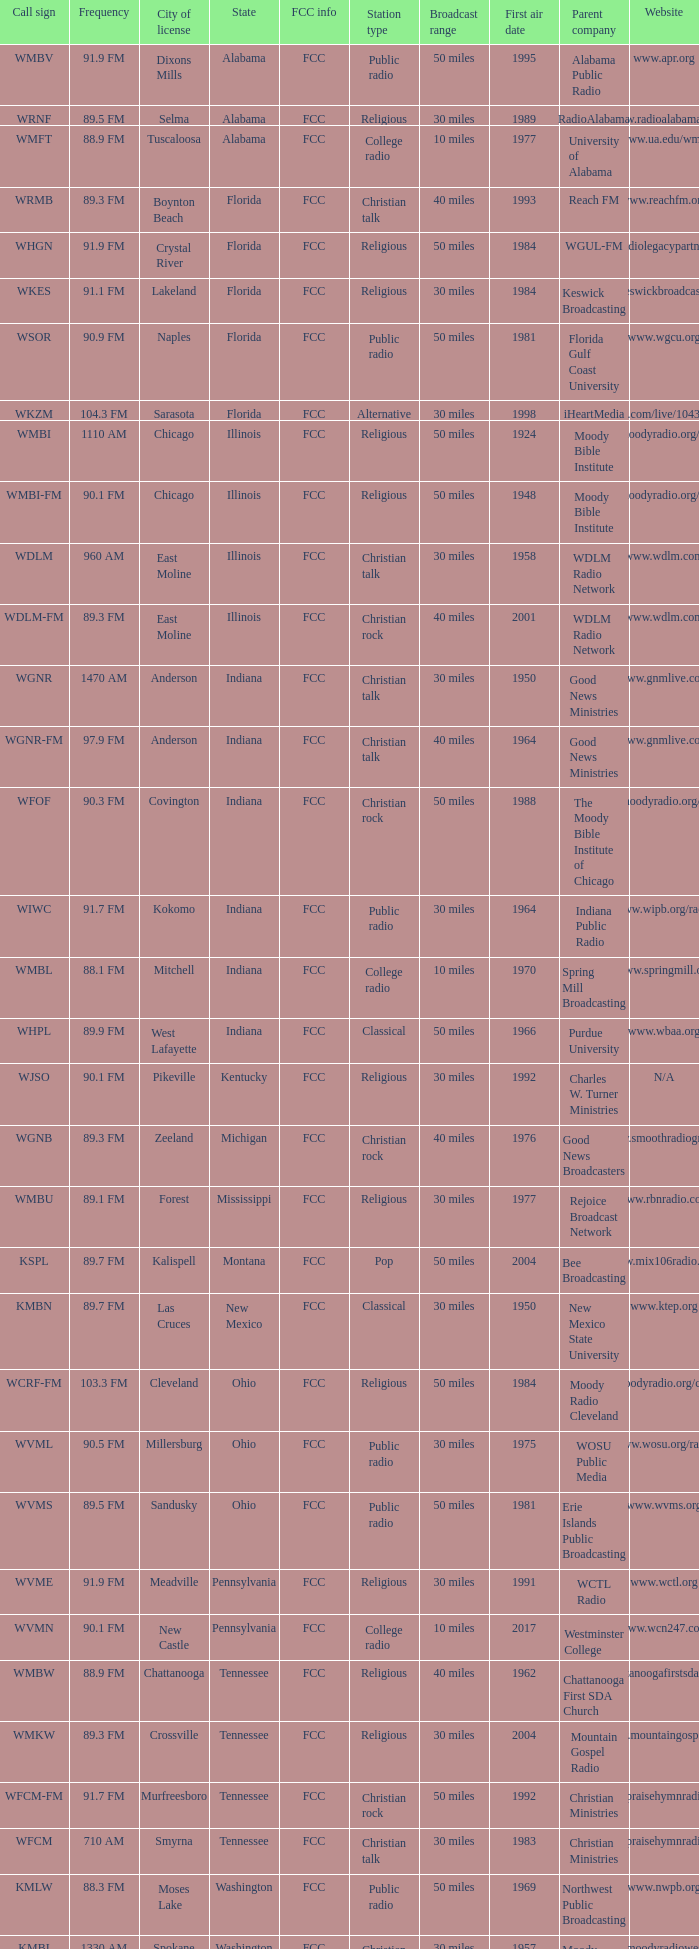What frequency does the wgnr-fm radio station operate on? 97.9 FM. Can you parse all the data within this table? {'header': ['Call sign', 'Frequency', 'City of license', 'State', 'FCC info', 'Station type', 'Broadcast range', 'First air date', 'Parent company', 'Website'], 'rows': [['WMBV', '91.9 FM', 'Dixons Mills', 'Alabama', 'FCC', 'Public radio', '50 miles', '1995', 'Alabama Public Radio', 'www.apr.org'], ['WRNF', '89.5 FM', 'Selma', 'Alabama', 'FCC', 'Religious', '30 miles', '1989', 'RadioAlabama', 'www.radioalabama.net'], ['WMFT', '88.9 FM', 'Tuscaloosa', 'Alabama', 'FCC', 'College radio', '10 miles', '1977', 'University of Alabama', 'www.ua.edu/wmft'], ['WRMB', '89.3 FM', 'Boynton Beach', 'Florida', 'FCC', 'Christian talk', '40 miles', '1993', 'Reach FM', 'www.reachfm.org'], ['WHGN', '91.9 FM', 'Crystal River', 'Florida', 'FCC', 'Religious', '50 miles', '1984', 'WGUL-FM', 'www.radiolegacypartners.com'], ['WKES', '91.1 FM', 'Lakeland', 'Florida', 'FCC', 'Religious', '30 miles', '1984', 'Keswick Broadcasting', 'www.keswickbroadcasting.org'], ['WSOR', '90.9 FM', 'Naples', 'Florida', 'FCC', 'Public radio', '50 miles', '1981', 'Florida Gulf Coast University', 'www.wgcu.org'], ['WKZM', '104.3 FM', 'Sarasota', 'Florida', 'FCC', 'Alternative', '30 miles', '1998', 'iHeartMedia', 'www.iheart.com/live/1043-kzm-4921/'], ['WMBI', '1110 AM', 'Chicago', 'Illinois', 'FCC', 'Religious', '50 miles', '1924', 'Moody Bible Institute', 'www.moodyradio.org/chicago'], ['WMBI-FM', '90.1 FM', 'Chicago', 'Illinois', 'FCC', 'Religious', '50 miles', '1948', 'Moody Bible Institute', 'www.moodyradio.org/chicago'], ['WDLM', '960 AM', 'East Moline', 'Illinois', 'FCC', 'Christian talk', '30 miles', '1958', 'WDLM Radio Network', 'www.wdlm.com'], ['WDLM-FM', '89.3 FM', 'East Moline', 'Illinois', 'FCC', 'Christian rock', '40 miles', '2001', 'WDLM Radio Network', 'www.wdlm.com'], ['WGNR', '1470 AM', 'Anderson', 'Indiana', 'FCC', 'Christian talk', '30 miles', '1950', 'Good News Ministries', 'www.gnmlive.com'], ['WGNR-FM', '97.9 FM', 'Anderson', 'Indiana', 'FCC', 'Christian talk', '40 miles', '1964', 'Good News Ministries', 'www.gnmlive.com'], ['WFOF', '90.3 FM', 'Covington', 'Indiana', 'FCC', 'Christian rock', '50 miles', '1988', 'The Moody Bible Institute of Chicago', 'www.moodyradio.org/indiana'], ['WIWC', '91.7 FM', 'Kokomo', 'Indiana', 'FCC', 'Public radio', '30 miles', '1964', 'Indiana Public Radio', 'www.wipb.org/radio'], ['WMBL', '88.1 FM', 'Mitchell', 'Indiana', 'FCC', 'College radio', '10 miles', '1970', 'Spring Mill Broadcasting', 'www.springmill.org'], ['WHPL', '89.9 FM', 'West Lafayette', 'Indiana', 'FCC', 'Classical', '50 miles', '1966', 'Purdue University', 'www.wbaa.org'], ['WJSO', '90.1 FM', 'Pikeville', 'Kentucky', 'FCC', 'Religious', '30 miles', '1992', 'Charles W. Turner Ministries', 'N/A'], ['WGNB', '89.3 FM', 'Zeeland', 'Michigan', 'FCC', 'Christian rock', '40 miles', '1976', 'Good News Broadcasters', 'www.smoothradiogr.com'], ['WMBU', '89.1 FM', 'Forest', 'Mississippi', 'FCC', 'Religious', '30 miles', '1977', 'Rejoice Broadcast Network', 'www.rbnradio.com'], ['KSPL', '89.7 FM', 'Kalispell', 'Montana', 'FCC', 'Pop', '50 miles', '2004', 'Bee Broadcasting', 'www.mix106radio.com'], ['KMBN', '89.7 FM', 'Las Cruces', 'New Mexico', 'FCC', 'Classical', '30 miles', '1950', 'New Mexico State University', 'www.ktep.org'], ['WCRF-FM', '103.3 FM', 'Cleveland', 'Ohio', 'FCC', 'Religious', '50 miles', '1984', 'Moody Radio Cleveland', 'www.moodyradio.org/cleveland'], ['WVML', '90.5 FM', 'Millersburg', 'Ohio', 'FCC', 'Public radio', '30 miles', '1975', 'WOSU Public Media', 'www.wosu.org/radio'], ['WVMS', '89.5 FM', 'Sandusky', 'Ohio', 'FCC', 'Public radio', '50 miles', '1981', 'Erie Islands Public Broadcasting', 'www.wvms.org'], ['WVME', '91.9 FM', 'Meadville', 'Pennsylvania', 'FCC', 'Religious', '30 miles', '1991', 'WCTL Radio', 'www.wctl.org'], ['WVMN', '90.1 FM', 'New Castle', 'Pennsylvania', 'FCC', 'College radio', '10 miles', '2017', 'Westminster College', 'www.wcn247.com'], ['WMBW', '88.9 FM', 'Chattanooga', 'Tennessee', 'FCC', 'Religious', '40 miles', '1962', 'Chattanooga First SDA Church', 'www.chattanoogafirstsda.com/radio'], ['WMKW', '89.3 FM', 'Crossville', 'Tennessee', 'FCC', 'Religious', '30 miles', '2004', 'Mountain Gospel Radio', 'www.mountaingospel.org'], ['WFCM-FM', '91.7 FM', 'Murfreesboro', 'Tennessee', 'FCC', 'Christian rock', '50 miles', '1992', 'Christian Ministries', 'www.praisehymnradio.com'], ['WFCM', '710 AM', 'Smyrna', 'Tennessee', 'FCC', 'Christian talk', '30 miles', '1983', 'Christian Ministries', 'www.praisehymnradio.com'], ['KMLW', '88.3 FM', 'Moses Lake', 'Washington', 'FCC', 'Public radio', '50 miles', '1969', 'Northwest Public Broadcasting', 'www.nwpb.org'], ['KMBI', '1330 AM', 'Spokane', 'Washington', 'FCC', 'Christian talk', '30 miles', '1957', 'Moody Broadcasting Network', 'www.moodyradiowest.com'], ['KMBI-FM', '107.9 FM', 'Spokane', 'Washington', 'FCC', 'Christian talk', '40 miles', '1962', 'Moody Broadcasting Network', 'www.moodyradiowest.com'], ['KMWY', '91.1 FM', 'Jackson', 'Wyoming', 'FCC', 'Classic rock', '50 miles', '2007', 'Lost Creek Broadcasting', 'www.1050classicrock.com']]} 